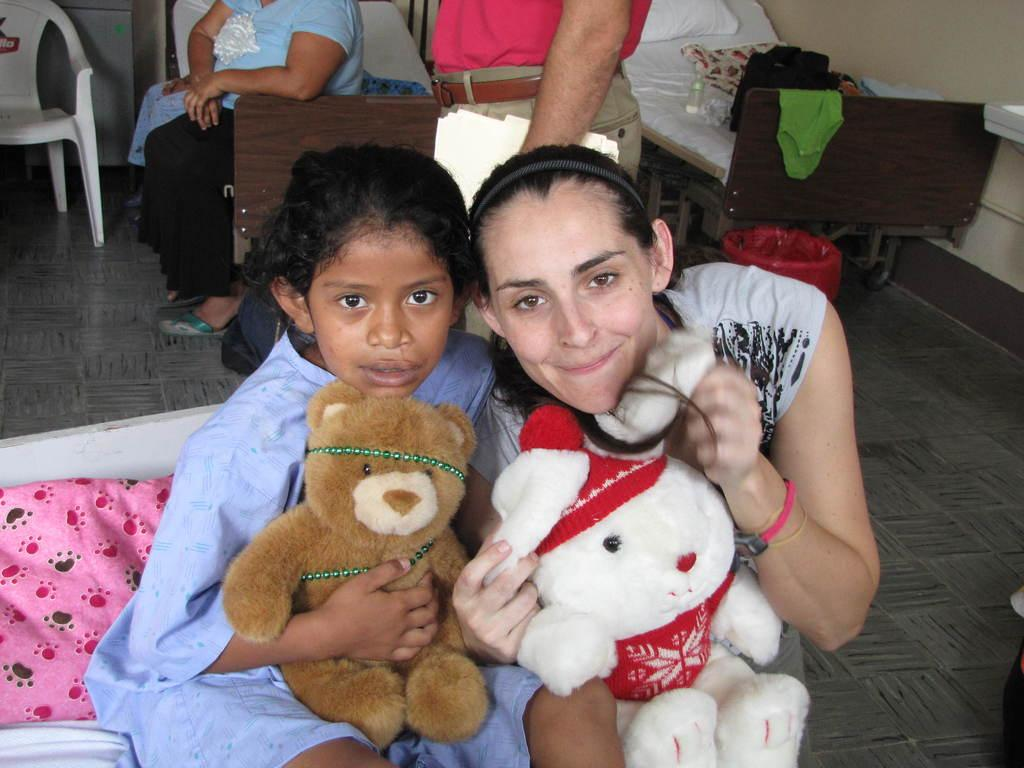Who are the main subjects in the image? There is a girl and a woman in the image. What are the girl and the woman holding? Both the girl and the woman are holding soft toys. What can be seen in the background of the image? There are people, two beds, and a chair in the background of the image. What type of jeans are the cows wearing in the image? There are no cows present in the image, and therefore no jeans can be observed. 